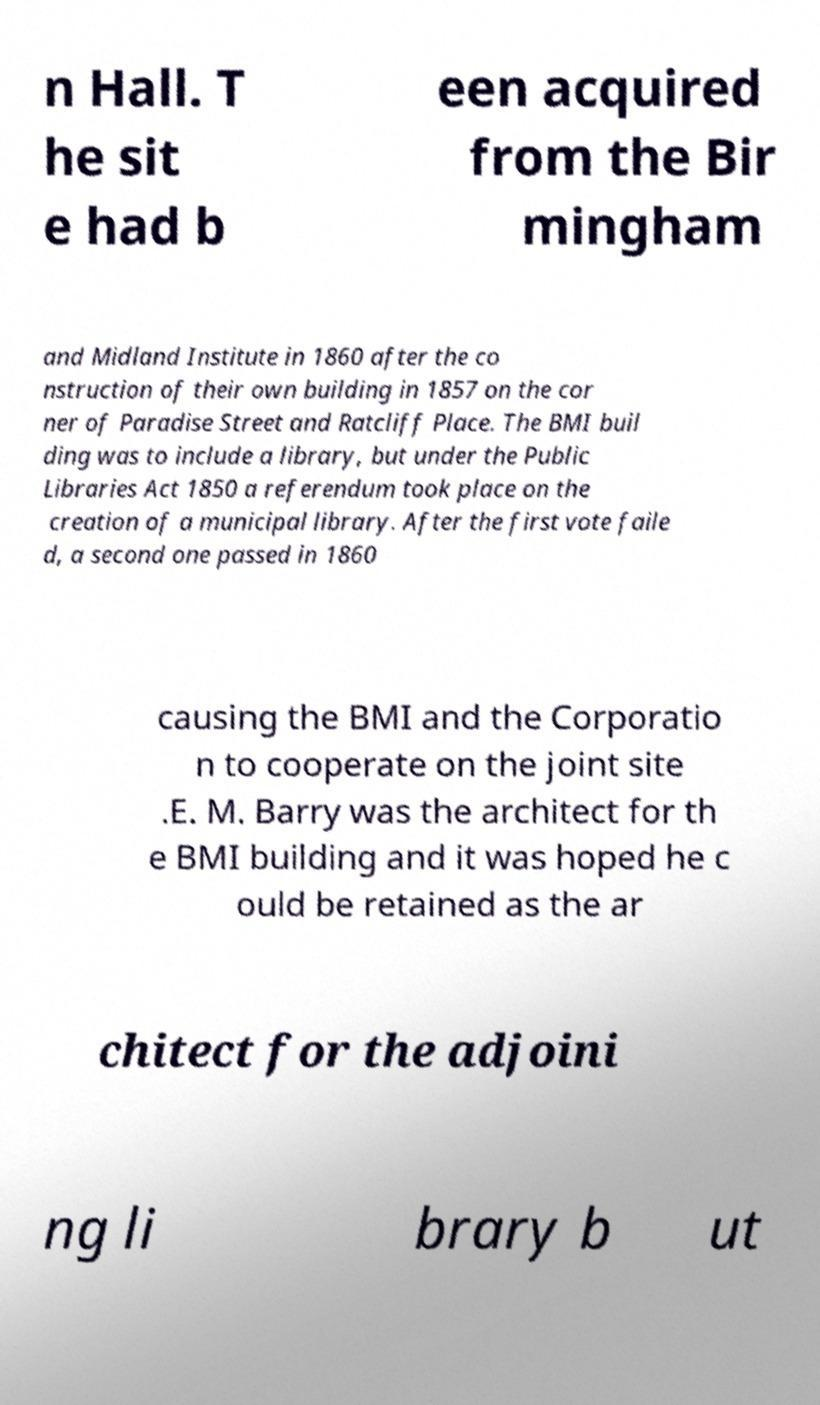Could you assist in decoding the text presented in this image and type it out clearly? n Hall. T he sit e had b een acquired from the Bir mingham and Midland Institute in 1860 after the co nstruction of their own building in 1857 on the cor ner of Paradise Street and Ratcliff Place. The BMI buil ding was to include a library, but under the Public Libraries Act 1850 a referendum took place on the creation of a municipal library. After the first vote faile d, a second one passed in 1860 causing the BMI and the Corporatio n to cooperate on the joint site .E. M. Barry was the architect for th e BMI building and it was hoped he c ould be retained as the ar chitect for the adjoini ng li brary b ut 